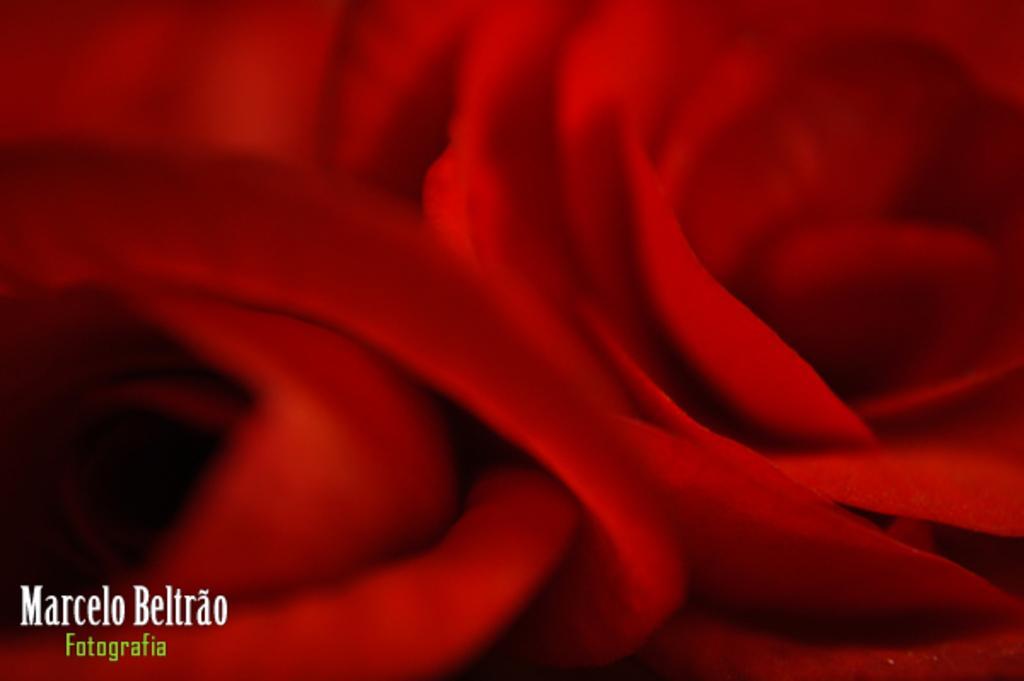Can you describe this image briefly? This is a zoom in picture of a red color flower as we can see in the middle of this image, and there is a text in the bottom left corner of this image. 